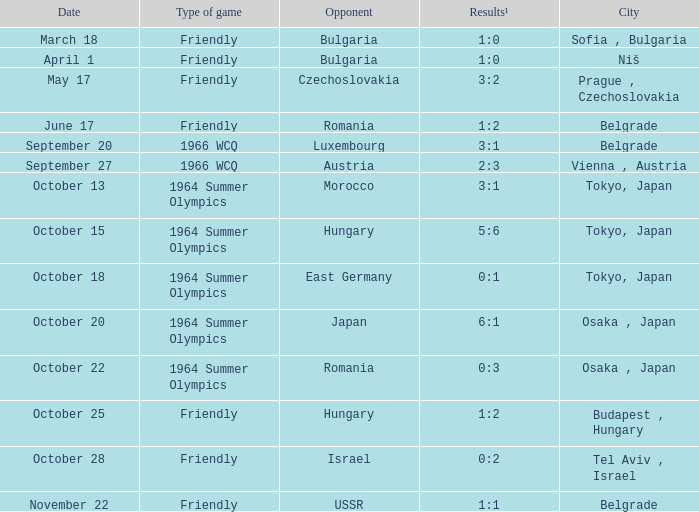On october 13, which city had a significant happening? Tokyo, Japan. 